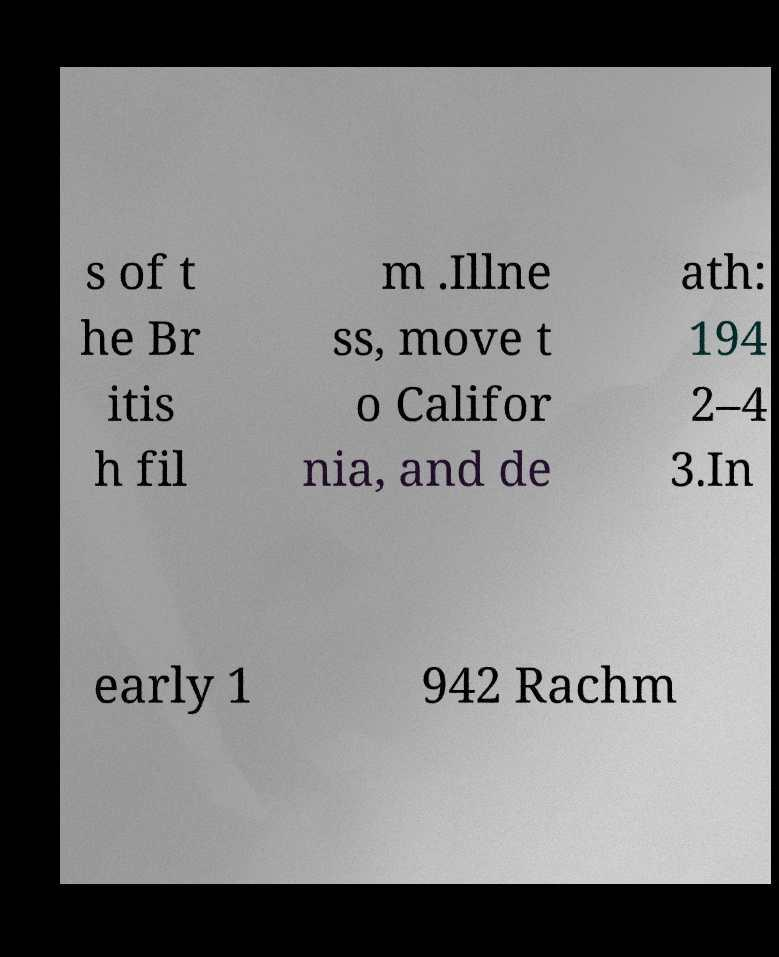Can you read and provide the text displayed in the image?This photo seems to have some interesting text. Can you extract and type it out for me? s of t he Br itis h fil m .Illne ss, move t o Califor nia, and de ath: 194 2–4 3.In early 1 942 Rachm 